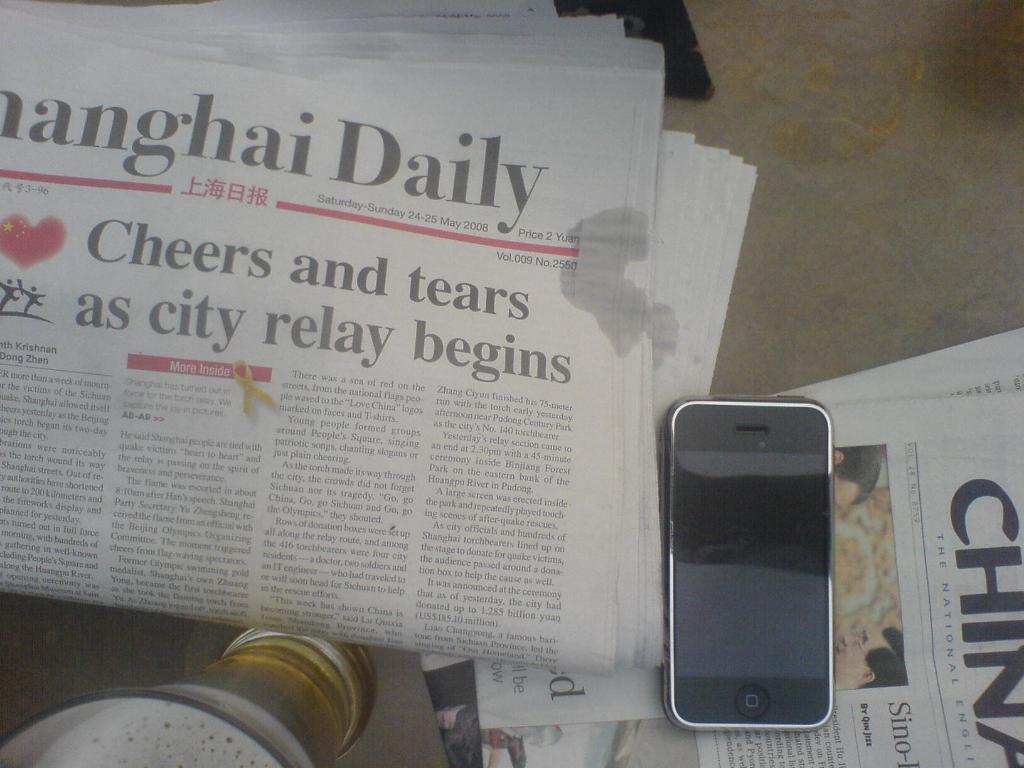What recently began and prompted cheers and tears?
Your response must be concise. City relay. 